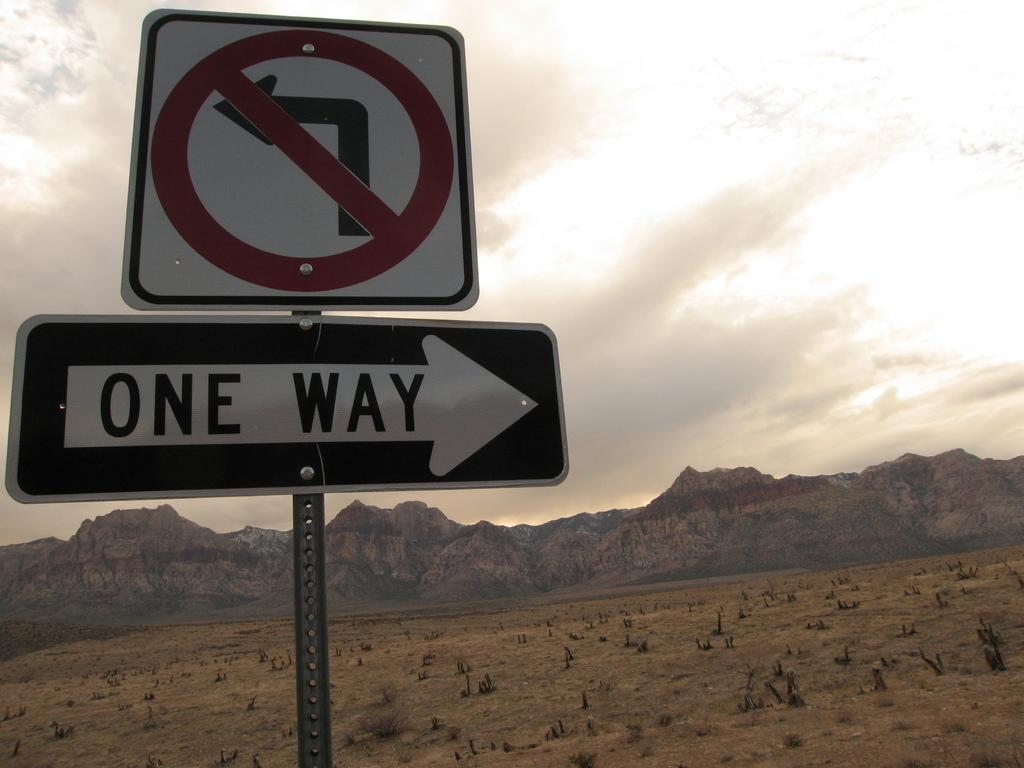<image>
Render a clear and concise summary of the photo. A black and white road sign indicates that a certain road goes only one way. 